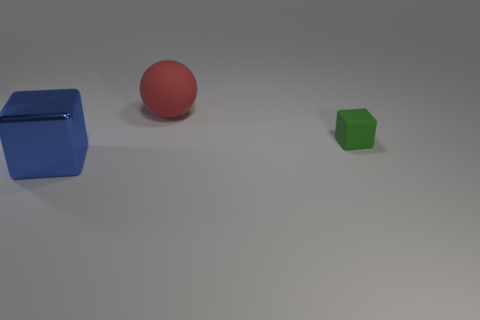Subtract all blue blocks. How many blocks are left? 1 Add 1 blocks. How many objects exist? 4 Subtract all spheres. How many objects are left? 2 Add 1 green blocks. How many green blocks are left? 2 Add 2 gray metallic things. How many gray metallic things exist? 2 Subtract 0 yellow blocks. How many objects are left? 3 Subtract all cyan spheres. Subtract all blue cubes. How many spheres are left? 1 Subtract all tiny cyan blocks. Subtract all big spheres. How many objects are left? 2 